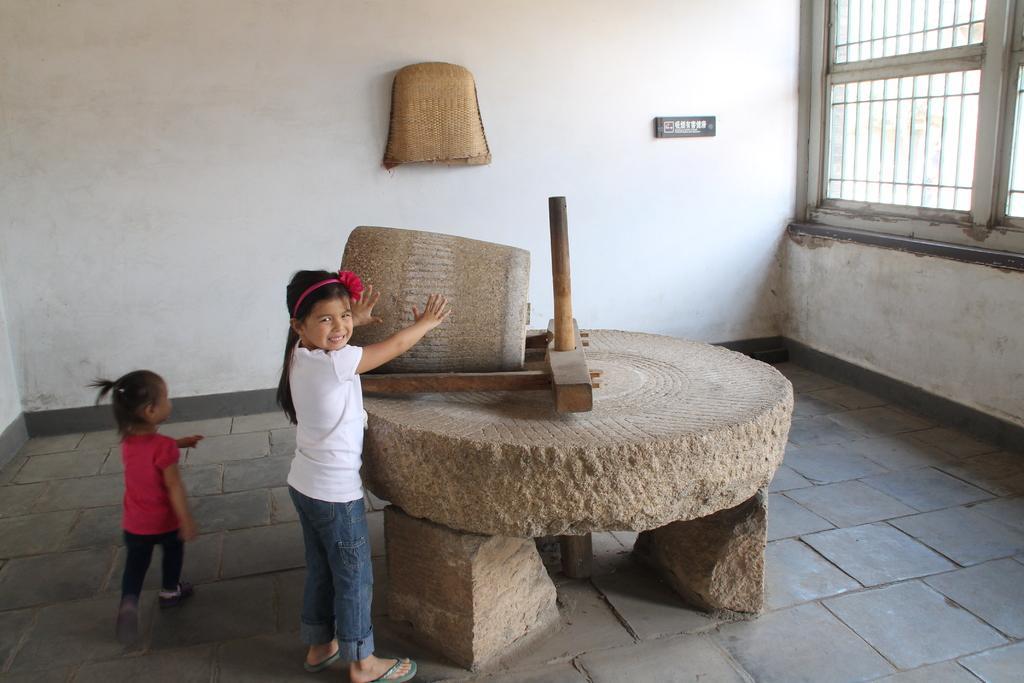How would you summarize this image in a sentence or two? In this picture there are two girls and we can see wooden object, stones and floor. In the background of the image we can see winnowing basket and board on the wall. We can see window. 